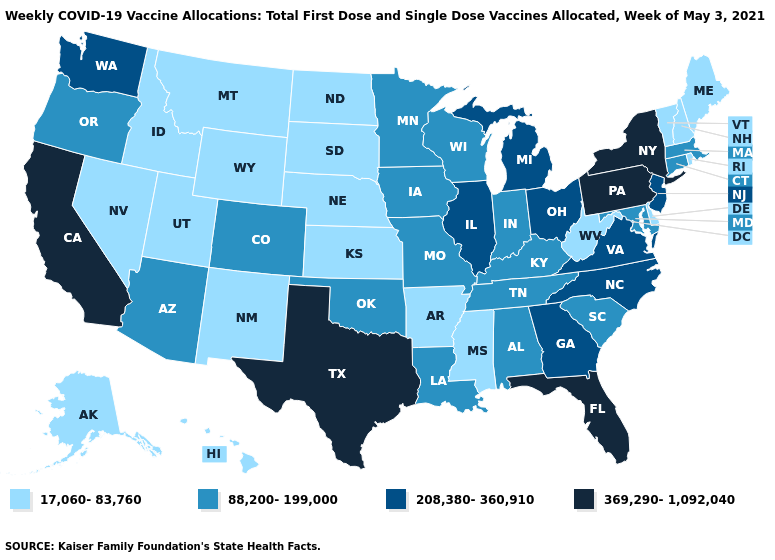Among the states that border Utah , which have the highest value?
Quick response, please. Arizona, Colorado. Does Kansas have the lowest value in the MidWest?
Short answer required. Yes. Name the states that have a value in the range 88,200-199,000?
Give a very brief answer. Alabama, Arizona, Colorado, Connecticut, Indiana, Iowa, Kentucky, Louisiana, Maryland, Massachusetts, Minnesota, Missouri, Oklahoma, Oregon, South Carolina, Tennessee, Wisconsin. What is the lowest value in the USA?
Quick response, please. 17,060-83,760. Name the states that have a value in the range 88,200-199,000?
Short answer required. Alabama, Arizona, Colorado, Connecticut, Indiana, Iowa, Kentucky, Louisiana, Maryland, Massachusetts, Minnesota, Missouri, Oklahoma, Oregon, South Carolina, Tennessee, Wisconsin. What is the value of Arkansas?
Short answer required. 17,060-83,760. What is the value of Kentucky?
Short answer required. 88,200-199,000. Among the states that border Oklahoma , which have the highest value?
Concise answer only. Texas. Does the first symbol in the legend represent the smallest category?
Be succinct. Yes. What is the value of Oklahoma?
Short answer required. 88,200-199,000. Does Oregon have the lowest value in the USA?
Short answer required. No. Does Missouri have the same value as Kentucky?
Quick response, please. Yes. Name the states that have a value in the range 208,380-360,910?
Answer briefly. Georgia, Illinois, Michigan, New Jersey, North Carolina, Ohio, Virginia, Washington. Does California have the highest value in the USA?
Be succinct. Yes. Which states hav the highest value in the Northeast?
Short answer required. New York, Pennsylvania. 